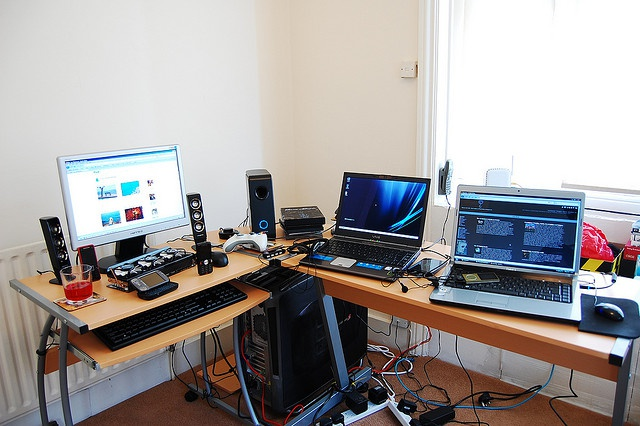Describe the objects in this image and their specific colors. I can see laptop in lightgray, black, navy, blue, and lightblue tones, laptop in lightgray, black, navy, gray, and lightblue tones, keyboard in lightgray, black, blue, and navy tones, keyboard in lightgray, black, gray, and blue tones, and cup in lightgray, brown, black, and tan tones in this image. 